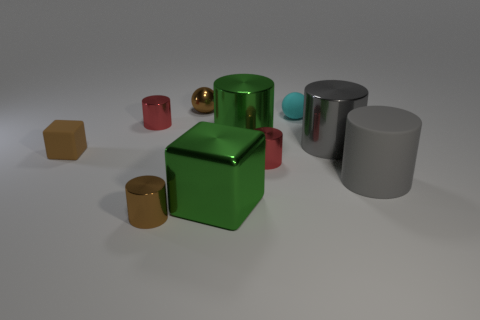Are there fewer tiny balls behind the tiny cyan sphere than objects that are in front of the small brown cube?
Your answer should be compact. Yes. How many big green cylinders have the same material as the small brown cube?
Make the answer very short. 0. Are there any big cylinders to the left of the red metallic cylinder that is on the left side of the green metallic object that is in front of the big green cylinder?
Provide a short and direct response. No. There is a large gray thing that is made of the same material as the large block; what is its shape?
Offer a very short reply. Cylinder. Is the number of small metal spheres greater than the number of big yellow objects?
Your answer should be compact. Yes. Does the cyan matte thing have the same shape as the small brown thing that is behind the cyan ball?
Ensure brevity in your answer.  Yes. What is the material of the tiny brown cube?
Ensure brevity in your answer.  Rubber. There is a small thing that is on the right side of the small red metal cylinder that is on the right side of the big block on the left side of the cyan sphere; what color is it?
Offer a terse response. Cyan. There is a tiny brown thing that is the same shape as the tiny cyan matte thing; what is it made of?
Your answer should be very brief. Metal. How many cyan objects have the same size as the green metal cylinder?
Your answer should be compact. 0. 